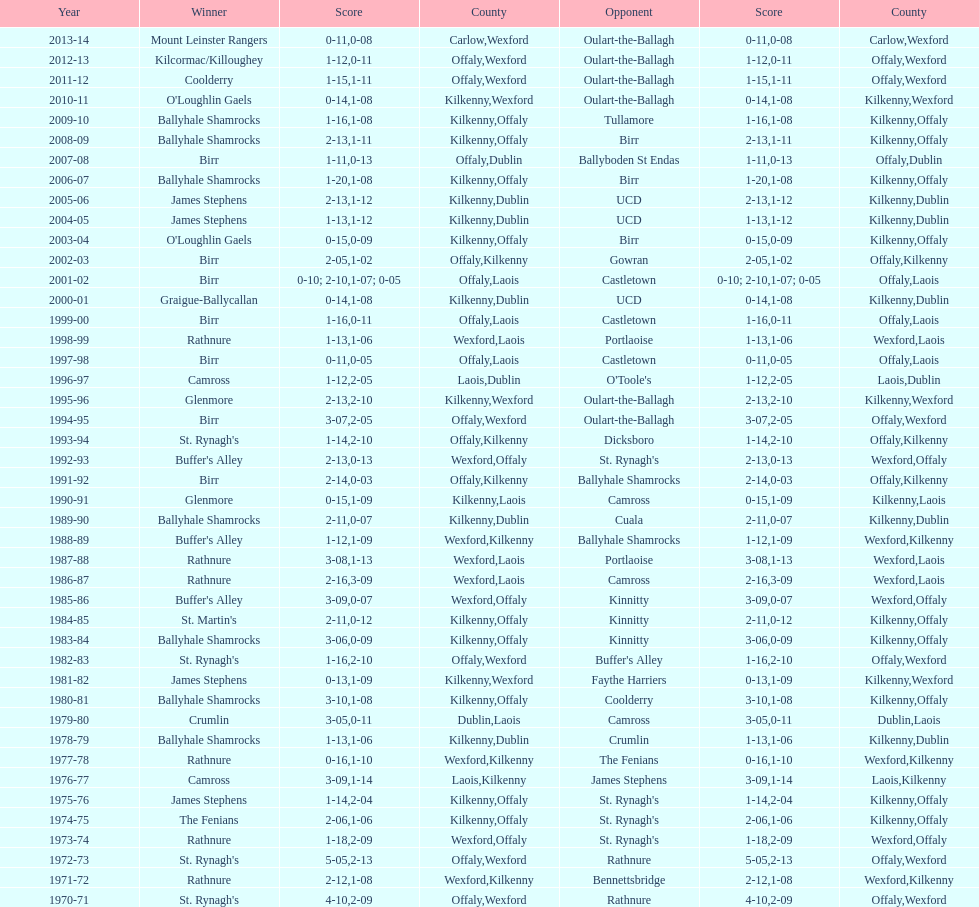Which conqueror is next to mount leinster rangers? Kilcormac/Killoughey. 